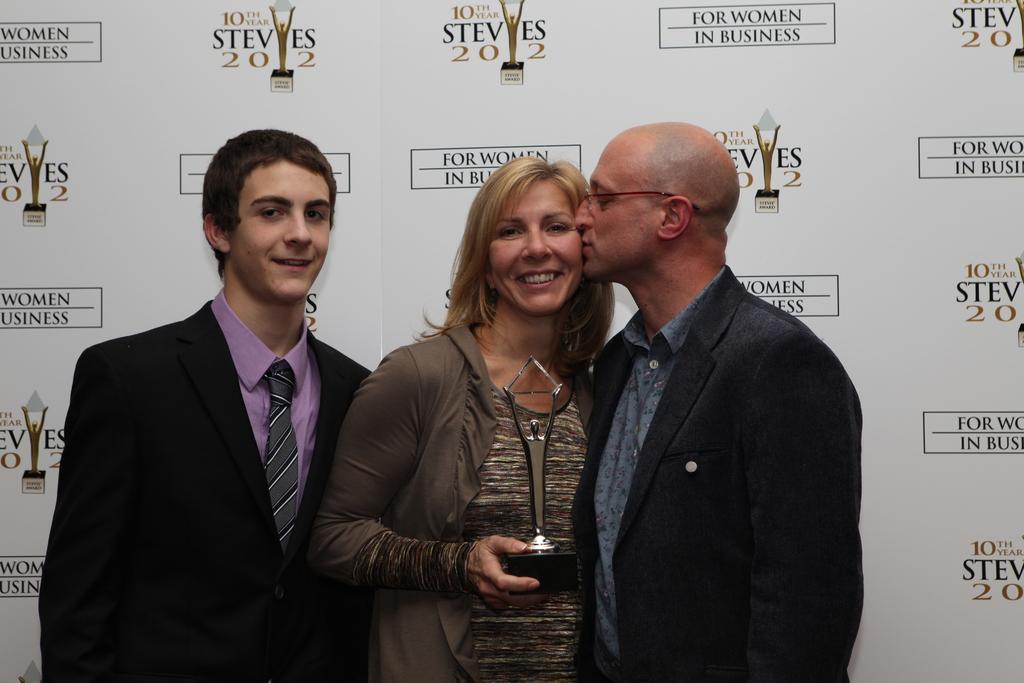Describe this image in one or two sentences. In this image I can see three persons standing in the middle person is holding an award. In the background there is a board. 